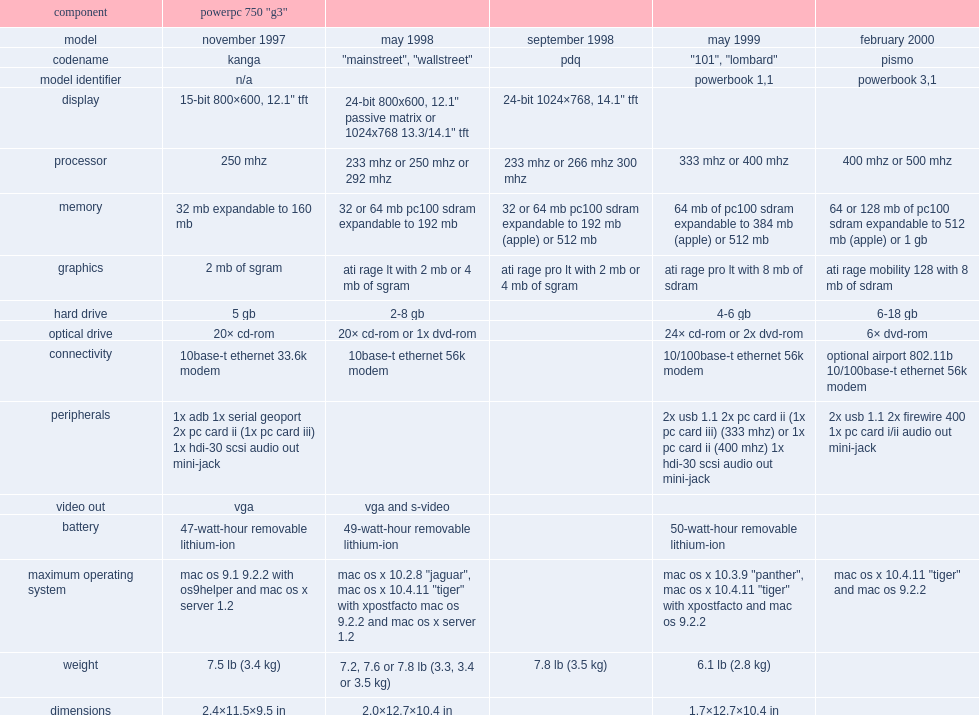What was processor's speed for the powerbook g3 model. 233 mhz or 266 mhz 300 mhz. 